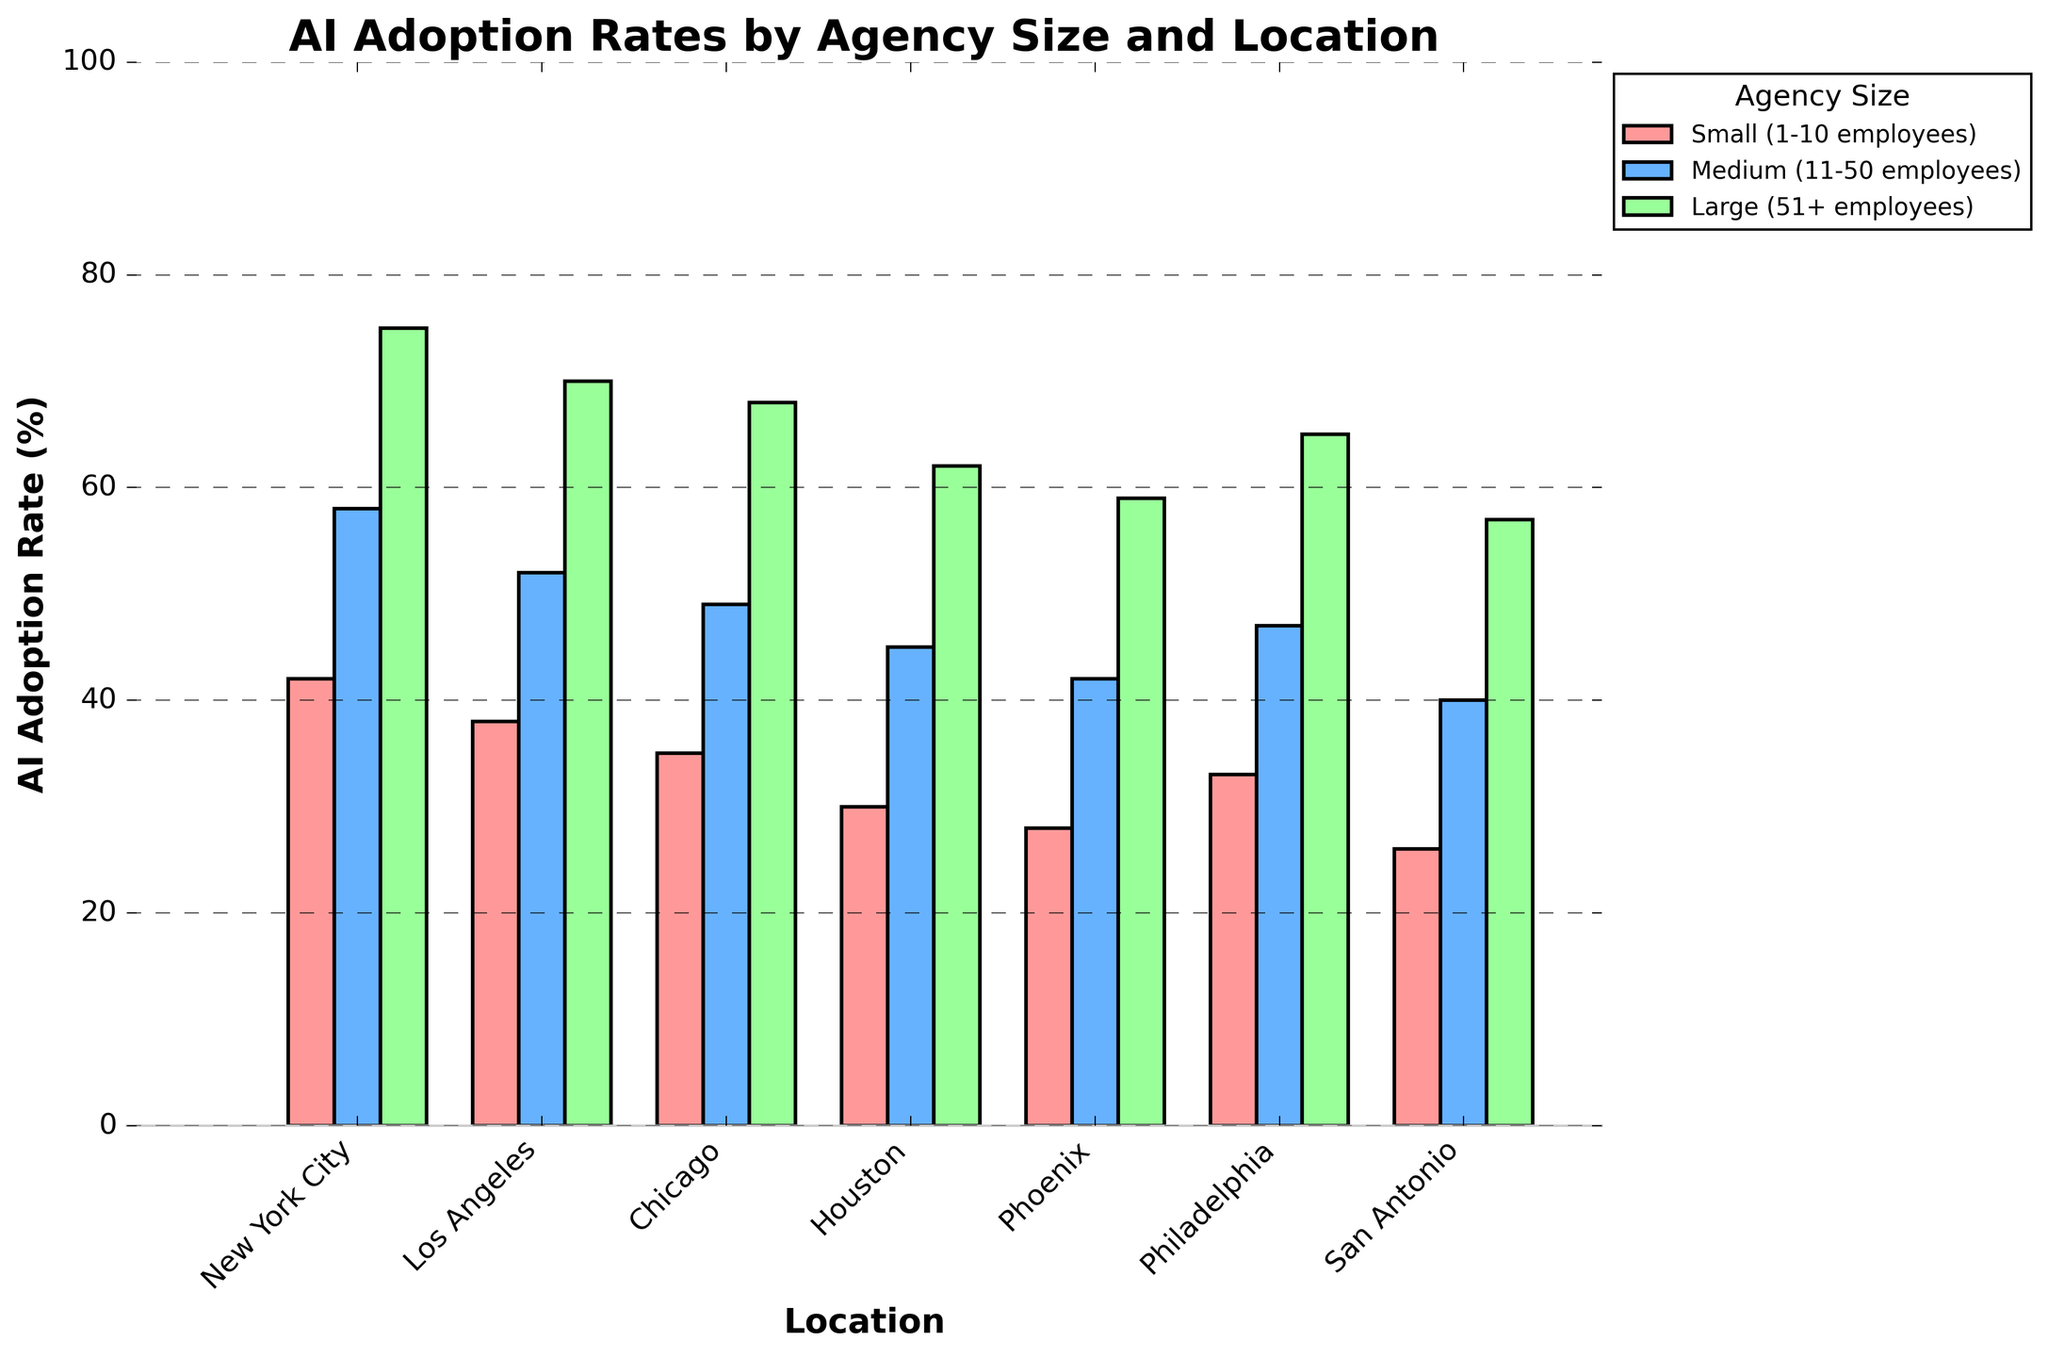What is the highest AI adoption rate for small agencies across all locations? To determine the highest adoption rate for small agencies, look at the bars corresponding to "Small (1-10 employees)" across all locations. The highest bar is in New York City at 42%.
Answer: 42% Which location has the lowest AI adoption rate for large agencies? Check the height of the bars corresponding to "Large (51+ employees)" across all locations. The lowest bar is in San Antonio at 57%.
Answer: San Antonio How does the AI adoption rate for medium-sized agencies in Los Angeles compare to that in Chicago? Compare the heights of the bars for "Medium (11-50 employees)" in Los Angeles and Chicago. Los Angeles has a rate of 52%, while Chicago has a rate of 49%. Los Angeles has a higher rate.
Answer: Los Angeles is higher What is the average AI adoption rate for all agency sizes in Phoenix? Calculate the average by adding the AI adoption rates for small (28%), medium (42%), and large (59%) agencies in Phoenix and then dividing by three: (28 + 42 + 59) / 3 = 43%.
Answer: 43% Three cities have the highest AI adoption rates for large agencies. Which are they and what are their rates? Identify the top three bars for "Large (51+ employees)" agencies. The highest rates are for New York City (75%), Los Angeles (70%), and Chicago (68%).
Answer: New York City (75%), Los Angeles (70%), and Chicago (68%) Which agency size has the most consistent AI adoption rates across all locations, and what is the range of adoption rates? For each agency size, find the range (difference between the highest and lowest rates) across all locations. 
- Small agencies: 42-26 = 16
- Medium agencies: 58-40 = 18
- Large agencies: 75-57 = 18
"Small (1-10 employees)" agencies have the most consistent rates with the smallest range of 16%.
Answer: Small agencies with a range of 16% In which city do small agencies have a higher AI adoption rate than medium-sized agencies in another city? Compare the AI adoption rates for small agencies in each city with those for medium-sized agencies in other cities.
- Small agencies in New York City (42) > Medium agencies in Phoenix (42)
- Small agencies in New York City (42) > Medium agencies in San Antonio (40)
Small agencies in New York City have a higher rate than medium agencies in Phoenix and San Antonio.
Answer: New York City vs. Phoenix and San Antonio 